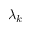<formula> <loc_0><loc_0><loc_500><loc_500>\lambda _ { k }</formula> 